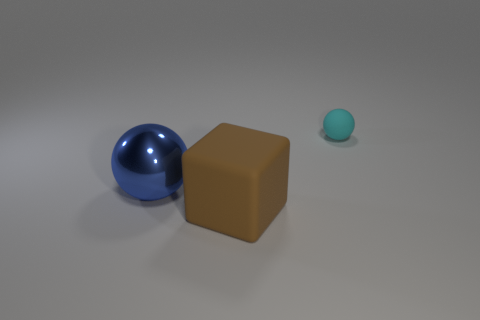Do the tiny cyan thing and the large thing that is right of the blue metal thing have the same material? While the tiny cyan object and the large brown cube are both solid objects within the image, their materials appear to be quite different. The tiny cyan object has a matte finish, suggesting it could be made of a plastic or ceramic, whereas the large brown cube has a flat, textureless surface that doesn't clearly indicate a specific material but suggests a non-metallic substance like wood or plastic. It's important to note, without tactile feedback or more detailed visual clues, such as reflections or surface texture, it's not possible to determine the material unequivocally from visual inspection alone. 